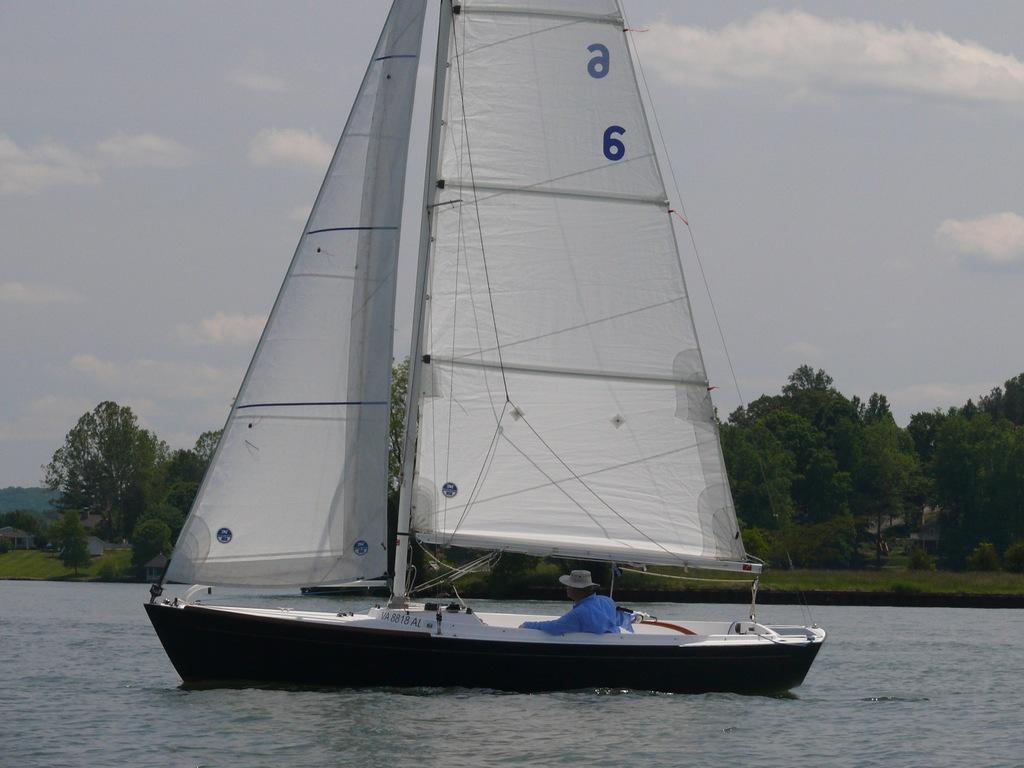What number is shown on the sail?
Your answer should be compact. 6. What is this boat's registration number?
Your response must be concise. Va 8818 al. 